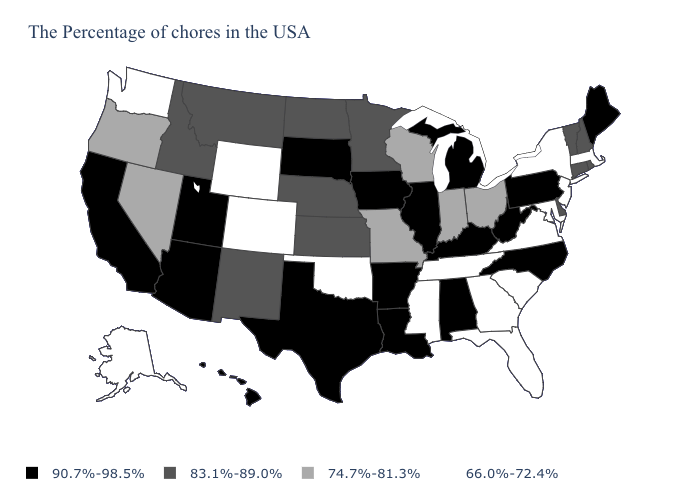Does Vermont have a lower value than Missouri?
Concise answer only. No. Name the states that have a value in the range 74.7%-81.3%?
Quick response, please. Ohio, Indiana, Wisconsin, Missouri, Nevada, Oregon. What is the value of Colorado?
Concise answer only. 66.0%-72.4%. Does Ohio have the lowest value in the USA?
Answer briefly. No. Does West Virginia have the highest value in the USA?
Concise answer only. Yes. Which states have the lowest value in the USA?
Concise answer only. Massachusetts, New York, New Jersey, Maryland, Virginia, South Carolina, Florida, Georgia, Tennessee, Mississippi, Oklahoma, Wyoming, Colorado, Washington, Alaska. What is the value of Kentucky?
Write a very short answer. 90.7%-98.5%. Does Pennsylvania have a higher value than Texas?
Keep it brief. No. Does Pennsylvania have the highest value in the Northeast?
Be succinct. Yes. Which states have the lowest value in the MidWest?
Quick response, please. Ohio, Indiana, Wisconsin, Missouri. Does Hawaii have the same value as Alabama?
Concise answer only. Yes. What is the lowest value in states that border Oklahoma?
Keep it brief. 66.0%-72.4%. Among the states that border New York , does Massachusetts have the lowest value?
Concise answer only. Yes. Name the states that have a value in the range 74.7%-81.3%?
Quick response, please. Ohio, Indiana, Wisconsin, Missouri, Nevada, Oregon. 